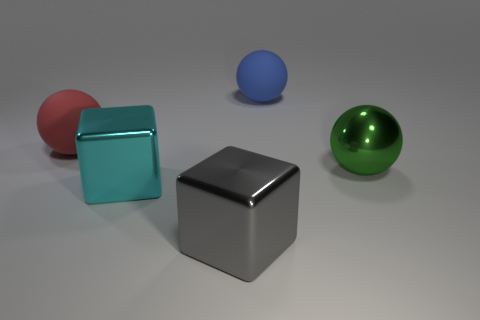Is the material of the cyan cube the same as the big red ball?
Keep it short and to the point. No. How many red things are on the left side of the ball that is left of the large cyan shiny block?
Make the answer very short. 0. The block that is the same size as the gray metal object is what color?
Offer a very short reply. Cyan. What is the big ball on the left side of the blue matte thing made of?
Ensure brevity in your answer.  Rubber. What is the large ball that is on the right side of the large red matte thing and to the left of the green sphere made of?
Your answer should be compact. Rubber. The gray metal object is what shape?
Your answer should be very brief. Cube. What number of large green objects have the same shape as the big cyan object?
Your response must be concise. 0. What number of objects are both in front of the blue ball and behind the gray thing?
Offer a very short reply. 3. The shiny ball is what color?
Make the answer very short. Green. Is there a large gray cube made of the same material as the blue object?
Your answer should be compact. No. 